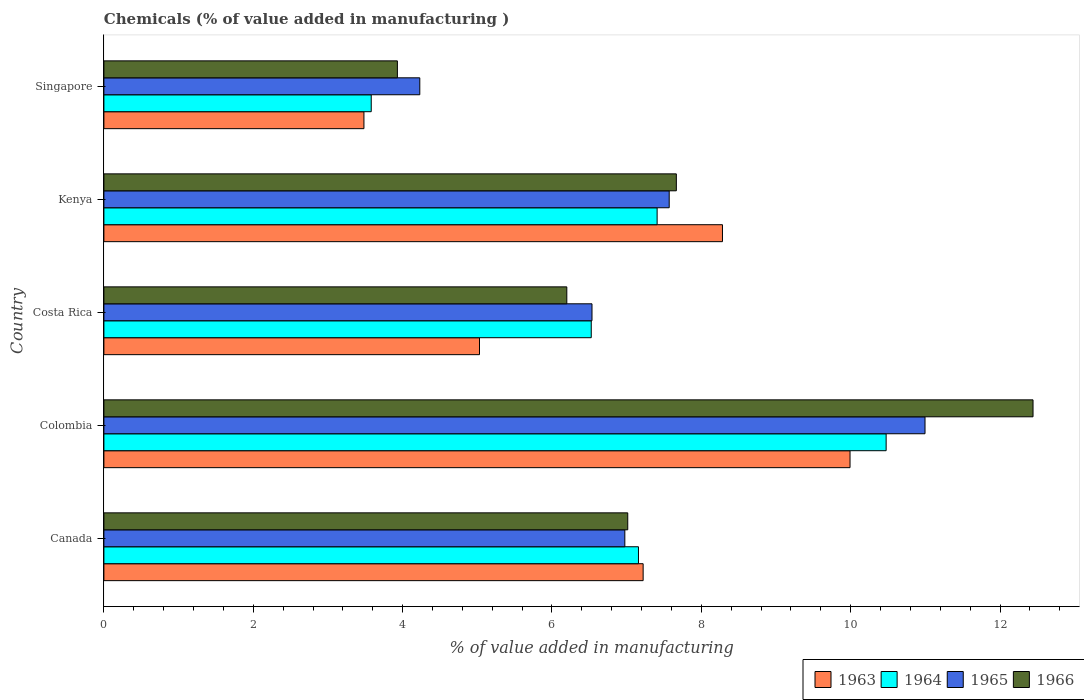How many groups of bars are there?
Give a very brief answer. 5. Are the number of bars per tick equal to the number of legend labels?
Make the answer very short. Yes. How many bars are there on the 4th tick from the bottom?
Offer a terse response. 4. What is the value added in manufacturing chemicals in 1964 in Kenya?
Make the answer very short. 7.41. Across all countries, what is the maximum value added in manufacturing chemicals in 1964?
Your answer should be compact. 10.47. Across all countries, what is the minimum value added in manufacturing chemicals in 1966?
Provide a succinct answer. 3.93. In which country was the value added in manufacturing chemicals in 1966 maximum?
Your answer should be compact. Colombia. In which country was the value added in manufacturing chemicals in 1965 minimum?
Your response must be concise. Singapore. What is the total value added in manufacturing chemicals in 1964 in the graph?
Make the answer very short. 35.15. What is the difference between the value added in manufacturing chemicals in 1965 in Canada and that in Singapore?
Your answer should be very brief. 2.75. What is the difference between the value added in manufacturing chemicals in 1965 in Colombia and the value added in manufacturing chemicals in 1963 in Kenya?
Your answer should be compact. 2.71. What is the average value added in manufacturing chemicals in 1966 per country?
Keep it short and to the point. 7.45. What is the difference between the value added in manufacturing chemicals in 1964 and value added in manufacturing chemicals in 1963 in Costa Rica?
Your answer should be very brief. 1.5. In how many countries, is the value added in manufacturing chemicals in 1964 greater than 6.4 %?
Your response must be concise. 4. What is the ratio of the value added in manufacturing chemicals in 1963 in Colombia to that in Singapore?
Offer a terse response. 2.87. Is the difference between the value added in manufacturing chemicals in 1964 in Kenya and Singapore greater than the difference between the value added in manufacturing chemicals in 1963 in Kenya and Singapore?
Give a very brief answer. No. What is the difference between the highest and the second highest value added in manufacturing chemicals in 1966?
Keep it short and to the point. 4.78. What is the difference between the highest and the lowest value added in manufacturing chemicals in 1966?
Ensure brevity in your answer.  8.51. In how many countries, is the value added in manufacturing chemicals in 1963 greater than the average value added in manufacturing chemicals in 1963 taken over all countries?
Make the answer very short. 3. Is the sum of the value added in manufacturing chemicals in 1966 in Canada and Costa Rica greater than the maximum value added in manufacturing chemicals in 1965 across all countries?
Your answer should be compact. Yes. What does the 2nd bar from the top in Singapore represents?
Your response must be concise. 1965. What does the 3rd bar from the bottom in Kenya represents?
Give a very brief answer. 1965. How many bars are there?
Your response must be concise. 20. How many countries are there in the graph?
Provide a succinct answer. 5. What is the difference between two consecutive major ticks on the X-axis?
Provide a succinct answer. 2. Are the values on the major ticks of X-axis written in scientific E-notation?
Your answer should be compact. No. Does the graph contain grids?
Your response must be concise. No. How many legend labels are there?
Your answer should be compact. 4. What is the title of the graph?
Provide a short and direct response. Chemicals (% of value added in manufacturing ). What is the label or title of the X-axis?
Offer a terse response. % of value added in manufacturing. What is the label or title of the Y-axis?
Offer a terse response. Country. What is the % of value added in manufacturing in 1963 in Canada?
Your answer should be compact. 7.22. What is the % of value added in manufacturing of 1964 in Canada?
Offer a terse response. 7.16. What is the % of value added in manufacturing in 1965 in Canada?
Provide a succinct answer. 6.98. What is the % of value added in manufacturing in 1966 in Canada?
Provide a succinct answer. 7.01. What is the % of value added in manufacturing in 1963 in Colombia?
Ensure brevity in your answer.  9.99. What is the % of value added in manufacturing in 1964 in Colombia?
Your response must be concise. 10.47. What is the % of value added in manufacturing of 1965 in Colombia?
Offer a terse response. 10.99. What is the % of value added in manufacturing in 1966 in Colombia?
Give a very brief answer. 12.44. What is the % of value added in manufacturing in 1963 in Costa Rica?
Your answer should be very brief. 5.03. What is the % of value added in manufacturing of 1964 in Costa Rica?
Offer a terse response. 6.53. What is the % of value added in manufacturing in 1965 in Costa Rica?
Offer a terse response. 6.54. What is the % of value added in manufacturing in 1966 in Costa Rica?
Give a very brief answer. 6.2. What is the % of value added in manufacturing of 1963 in Kenya?
Your answer should be compact. 8.28. What is the % of value added in manufacturing in 1964 in Kenya?
Give a very brief answer. 7.41. What is the % of value added in manufacturing of 1965 in Kenya?
Your answer should be very brief. 7.57. What is the % of value added in manufacturing in 1966 in Kenya?
Ensure brevity in your answer.  7.67. What is the % of value added in manufacturing in 1963 in Singapore?
Keep it short and to the point. 3.48. What is the % of value added in manufacturing of 1964 in Singapore?
Your answer should be very brief. 3.58. What is the % of value added in manufacturing of 1965 in Singapore?
Provide a short and direct response. 4.23. What is the % of value added in manufacturing of 1966 in Singapore?
Your answer should be compact. 3.93. Across all countries, what is the maximum % of value added in manufacturing in 1963?
Your answer should be compact. 9.99. Across all countries, what is the maximum % of value added in manufacturing of 1964?
Offer a terse response. 10.47. Across all countries, what is the maximum % of value added in manufacturing in 1965?
Your answer should be very brief. 10.99. Across all countries, what is the maximum % of value added in manufacturing in 1966?
Offer a very short reply. 12.44. Across all countries, what is the minimum % of value added in manufacturing of 1963?
Your answer should be compact. 3.48. Across all countries, what is the minimum % of value added in manufacturing of 1964?
Keep it short and to the point. 3.58. Across all countries, what is the minimum % of value added in manufacturing of 1965?
Ensure brevity in your answer.  4.23. Across all countries, what is the minimum % of value added in manufacturing in 1966?
Ensure brevity in your answer.  3.93. What is the total % of value added in manufacturing of 1963 in the graph?
Your answer should be compact. 34.01. What is the total % of value added in manufacturing in 1964 in the graph?
Keep it short and to the point. 35.15. What is the total % of value added in manufacturing of 1965 in the graph?
Ensure brevity in your answer.  36.31. What is the total % of value added in manufacturing in 1966 in the graph?
Keep it short and to the point. 37.25. What is the difference between the % of value added in manufacturing of 1963 in Canada and that in Colombia?
Your answer should be very brief. -2.77. What is the difference between the % of value added in manufacturing of 1964 in Canada and that in Colombia?
Offer a very short reply. -3.32. What is the difference between the % of value added in manufacturing of 1965 in Canada and that in Colombia?
Offer a very short reply. -4.02. What is the difference between the % of value added in manufacturing in 1966 in Canada and that in Colombia?
Ensure brevity in your answer.  -5.43. What is the difference between the % of value added in manufacturing of 1963 in Canada and that in Costa Rica?
Your answer should be very brief. 2.19. What is the difference between the % of value added in manufacturing of 1964 in Canada and that in Costa Rica?
Provide a short and direct response. 0.63. What is the difference between the % of value added in manufacturing in 1965 in Canada and that in Costa Rica?
Provide a succinct answer. 0.44. What is the difference between the % of value added in manufacturing of 1966 in Canada and that in Costa Rica?
Your response must be concise. 0.82. What is the difference between the % of value added in manufacturing of 1963 in Canada and that in Kenya?
Offer a terse response. -1.06. What is the difference between the % of value added in manufacturing in 1964 in Canada and that in Kenya?
Offer a very short reply. -0.25. What is the difference between the % of value added in manufacturing in 1965 in Canada and that in Kenya?
Your response must be concise. -0.59. What is the difference between the % of value added in manufacturing in 1966 in Canada and that in Kenya?
Your answer should be compact. -0.65. What is the difference between the % of value added in manufacturing of 1963 in Canada and that in Singapore?
Offer a very short reply. 3.74. What is the difference between the % of value added in manufacturing of 1964 in Canada and that in Singapore?
Keep it short and to the point. 3.58. What is the difference between the % of value added in manufacturing in 1965 in Canada and that in Singapore?
Provide a short and direct response. 2.75. What is the difference between the % of value added in manufacturing of 1966 in Canada and that in Singapore?
Ensure brevity in your answer.  3.08. What is the difference between the % of value added in manufacturing in 1963 in Colombia and that in Costa Rica?
Give a very brief answer. 4.96. What is the difference between the % of value added in manufacturing in 1964 in Colombia and that in Costa Rica?
Your answer should be compact. 3.95. What is the difference between the % of value added in manufacturing of 1965 in Colombia and that in Costa Rica?
Provide a short and direct response. 4.46. What is the difference between the % of value added in manufacturing in 1966 in Colombia and that in Costa Rica?
Offer a terse response. 6.24. What is the difference between the % of value added in manufacturing in 1963 in Colombia and that in Kenya?
Give a very brief answer. 1.71. What is the difference between the % of value added in manufacturing of 1964 in Colombia and that in Kenya?
Give a very brief answer. 3.07. What is the difference between the % of value added in manufacturing in 1965 in Colombia and that in Kenya?
Make the answer very short. 3.43. What is the difference between the % of value added in manufacturing in 1966 in Colombia and that in Kenya?
Your response must be concise. 4.78. What is the difference between the % of value added in manufacturing of 1963 in Colombia and that in Singapore?
Make the answer very short. 6.51. What is the difference between the % of value added in manufacturing in 1964 in Colombia and that in Singapore?
Keep it short and to the point. 6.89. What is the difference between the % of value added in manufacturing in 1965 in Colombia and that in Singapore?
Provide a short and direct response. 6.76. What is the difference between the % of value added in manufacturing in 1966 in Colombia and that in Singapore?
Provide a succinct answer. 8.51. What is the difference between the % of value added in manufacturing of 1963 in Costa Rica and that in Kenya?
Make the answer very short. -3.25. What is the difference between the % of value added in manufacturing in 1964 in Costa Rica and that in Kenya?
Provide a short and direct response. -0.88. What is the difference between the % of value added in manufacturing in 1965 in Costa Rica and that in Kenya?
Offer a terse response. -1.03. What is the difference between the % of value added in manufacturing of 1966 in Costa Rica and that in Kenya?
Ensure brevity in your answer.  -1.47. What is the difference between the % of value added in manufacturing of 1963 in Costa Rica and that in Singapore?
Offer a terse response. 1.55. What is the difference between the % of value added in manufacturing in 1964 in Costa Rica and that in Singapore?
Your answer should be very brief. 2.95. What is the difference between the % of value added in manufacturing of 1965 in Costa Rica and that in Singapore?
Offer a very short reply. 2.31. What is the difference between the % of value added in manufacturing in 1966 in Costa Rica and that in Singapore?
Offer a very short reply. 2.27. What is the difference between the % of value added in manufacturing in 1963 in Kenya and that in Singapore?
Keep it short and to the point. 4.8. What is the difference between the % of value added in manufacturing in 1964 in Kenya and that in Singapore?
Your response must be concise. 3.83. What is the difference between the % of value added in manufacturing in 1965 in Kenya and that in Singapore?
Provide a succinct answer. 3.34. What is the difference between the % of value added in manufacturing of 1966 in Kenya and that in Singapore?
Your answer should be compact. 3.74. What is the difference between the % of value added in manufacturing of 1963 in Canada and the % of value added in manufacturing of 1964 in Colombia?
Your response must be concise. -3.25. What is the difference between the % of value added in manufacturing in 1963 in Canada and the % of value added in manufacturing in 1965 in Colombia?
Offer a very short reply. -3.77. What is the difference between the % of value added in manufacturing in 1963 in Canada and the % of value added in manufacturing in 1966 in Colombia?
Keep it short and to the point. -5.22. What is the difference between the % of value added in manufacturing in 1964 in Canada and the % of value added in manufacturing in 1965 in Colombia?
Your response must be concise. -3.84. What is the difference between the % of value added in manufacturing in 1964 in Canada and the % of value added in manufacturing in 1966 in Colombia?
Offer a terse response. -5.28. What is the difference between the % of value added in manufacturing in 1965 in Canada and the % of value added in manufacturing in 1966 in Colombia?
Keep it short and to the point. -5.47. What is the difference between the % of value added in manufacturing of 1963 in Canada and the % of value added in manufacturing of 1964 in Costa Rica?
Offer a very short reply. 0.69. What is the difference between the % of value added in manufacturing in 1963 in Canada and the % of value added in manufacturing in 1965 in Costa Rica?
Your answer should be compact. 0.68. What is the difference between the % of value added in manufacturing in 1963 in Canada and the % of value added in manufacturing in 1966 in Costa Rica?
Provide a short and direct response. 1.02. What is the difference between the % of value added in manufacturing of 1964 in Canada and the % of value added in manufacturing of 1965 in Costa Rica?
Provide a short and direct response. 0.62. What is the difference between the % of value added in manufacturing of 1964 in Canada and the % of value added in manufacturing of 1966 in Costa Rica?
Provide a short and direct response. 0.96. What is the difference between the % of value added in manufacturing of 1965 in Canada and the % of value added in manufacturing of 1966 in Costa Rica?
Keep it short and to the point. 0.78. What is the difference between the % of value added in manufacturing in 1963 in Canada and the % of value added in manufacturing in 1964 in Kenya?
Ensure brevity in your answer.  -0.19. What is the difference between the % of value added in manufacturing of 1963 in Canada and the % of value added in manufacturing of 1965 in Kenya?
Keep it short and to the point. -0.35. What is the difference between the % of value added in manufacturing of 1963 in Canada and the % of value added in manufacturing of 1966 in Kenya?
Give a very brief answer. -0.44. What is the difference between the % of value added in manufacturing of 1964 in Canada and the % of value added in manufacturing of 1965 in Kenya?
Provide a succinct answer. -0.41. What is the difference between the % of value added in manufacturing of 1964 in Canada and the % of value added in manufacturing of 1966 in Kenya?
Give a very brief answer. -0.51. What is the difference between the % of value added in manufacturing in 1965 in Canada and the % of value added in manufacturing in 1966 in Kenya?
Offer a very short reply. -0.69. What is the difference between the % of value added in manufacturing of 1963 in Canada and the % of value added in manufacturing of 1964 in Singapore?
Give a very brief answer. 3.64. What is the difference between the % of value added in manufacturing in 1963 in Canada and the % of value added in manufacturing in 1965 in Singapore?
Provide a succinct answer. 2.99. What is the difference between the % of value added in manufacturing in 1963 in Canada and the % of value added in manufacturing in 1966 in Singapore?
Offer a terse response. 3.29. What is the difference between the % of value added in manufacturing in 1964 in Canada and the % of value added in manufacturing in 1965 in Singapore?
Keep it short and to the point. 2.93. What is the difference between the % of value added in manufacturing of 1964 in Canada and the % of value added in manufacturing of 1966 in Singapore?
Your answer should be very brief. 3.23. What is the difference between the % of value added in manufacturing in 1965 in Canada and the % of value added in manufacturing in 1966 in Singapore?
Make the answer very short. 3.05. What is the difference between the % of value added in manufacturing of 1963 in Colombia and the % of value added in manufacturing of 1964 in Costa Rica?
Offer a very short reply. 3.47. What is the difference between the % of value added in manufacturing in 1963 in Colombia and the % of value added in manufacturing in 1965 in Costa Rica?
Provide a short and direct response. 3.46. What is the difference between the % of value added in manufacturing in 1963 in Colombia and the % of value added in manufacturing in 1966 in Costa Rica?
Offer a terse response. 3.79. What is the difference between the % of value added in manufacturing of 1964 in Colombia and the % of value added in manufacturing of 1965 in Costa Rica?
Ensure brevity in your answer.  3.94. What is the difference between the % of value added in manufacturing of 1964 in Colombia and the % of value added in manufacturing of 1966 in Costa Rica?
Offer a terse response. 4.28. What is the difference between the % of value added in manufacturing of 1965 in Colombia and the % of value added in manufacturing of 1966 in Costa Rica?
Offer a terse response. 4.8. What is the difference between the % of value added in manufacturing of 1963 in Colombia and the % of value added in manufacturing of 1964 in Kenya?
Make the answer very short. 2.58. What is the difference between the % of value added in manufacturing in 1963 in Colombia and the % of value added in manufacturing in 1965 in Kenya?
Your response must be concise. 2.42. What is the difference between the % of value added in manufacturing in 1963 in Colombia and the % of value added in manufacturing in 1966 in Kenya?
Provide a succinct answer. 2.33. What is the difference between the % of value added in manufacturing of 1964 in Colombia and the % of value added in manufacturing of 1965 in Kenya?
Offer a very short reply. 2.9. What is the difference between the % of value added in manufacturing in 1964 in Colombia and the % of value added in manufacturing in 1966 in Kenya?
Give a very brief answer. 2.81. What is the difference between the % of value added in manufacturing of 1965 in Colombia and the % of value added in manufacturing of 1966 in Kenya?
Give a very brief answer. 3.33. What is the difference between the % of value added in manufacturing in 1963 in Colombia and the % of value added in manufacturing in 1964 in Singapore?
Keep it short and to the point. 6.41. What is the difference between the % of value added in manufacturing of 1963 in Colombia and the % of value added in manufacturing of 1965 in Singapore?
Your answer should be very brief. 5.76. What is the difference between the % of value added in manufacturing in 1963 in Colombia and the % of value added in manufacturing in 1966 in Singapore?
Make the answer very short. 6.06. What is the difference between the % of value added in manufacturing in 1964 in Colombia and the % of value added in manufacturing in 1965 in Singapore?
Make the answer very short. 6.24. What is the difference between the % of value added in manufacturing in 1964 in Colombia and the % of value added in manufacturing in 1966 in Singapore?
Your response must be concise. 6.54. What is the difference between the % of value added in manufacturing of 1965 in Colombia and the % of value added in manufacturing of 1966 in Singapore?
Keep it short and to the point. 7.07. What is the difference between the % of value added in manufacturing in 1963 in Costa Rica and the % of value added in manufacturing in 1964 in Kenya?
Provide a succinct answer. -2.38. What is the difference between the % of value added in manufacturing of 1963 in Costa Rica and the % of value added in manufacturing of 1965 in Kenya?
Ensure brevity in your answer.  -2.54. What is the difference between the % of value added in manufacturing in 1963 in Costa Rica and the % of value added in manufacturing in 1966 in Kenya?
Offer a very short reply. -2.64. What is the difference between the % of value added in manufacturing of 1964 in Costa Rica and the % of value added in manufacturing of 1965 in Kenya?
Make the answer very short. -1.04. What is the difference between the % of value added in manufacturing of 1964 in Costa Rica and the % of value added in manufacturing of 1966 in Kenya?
Your answer should be very brief. -1.14. What is the difference between the % of value added in manufacturing of 1965 in Costa Rica and the % of value added in manufacturing of 1966 in Kenya?
Provide a succinct answer. -1.13. What is the difference between the % of value added in manufacturing in 1963 in Costa Rica and the % of value added in manufacturing in 1964 in Singapore?
Ensure brevity in your answer.  1.45. What is the difference between the % of value added in manufacturing in 1963 in Costa Rica and the % of value added in manufacturing in 1965 in Singapore?
Your answer should be compact. 0.8. What is the difference between the % of value added in manufacturing in 1963 in Costa Rica and the % of value added in manufacturing in 1966 in Singapore?
Your response must be concise. 1.1. What is the difference between the % of value added in manufacturing in 1964 in Costa Rica and the % of value added in manufacturing in 1965 in Singapore?
Make the answer very short. 2.3. What is the difference between the % of value added in manufacturing of 1964 in Costa Rica and the % of value added in manufacturing of 1966 in Singapore?
Your answer should be compact. 2.6. What is the difference between the % of value added in manufacturing in 1965 in Costa Rica and the % of value added in manufacturing in 1966 in Singapore?
Give a very brief answer. 2.61. What is the difference between the % of value added in manufacturing in 1963 in Kenya and the % of value added in manufacturing in 1964 in Singapore?
Provide a succinct answer. 4.7. What is the difference between the % of value added in manufacturing of 1963 in Kenya and the % of value added in manufacturing of 1965 in Singapore?
Your response must be concise. 4.05. What is the difference between the % of value added in manufacturing of 1963 in Kenya and the % of value added in manufacturing of 1966 in Singapore?
Make the answer very short. 4.35. What is the difference between the % of value added in manufacturing in 1964 in Kenya and the % of value added in manufacturing in 1965 in Singapore?
Your answer should be very brief. 3.18. What is the difference between the % of value added in manufacturing of 1964 in Kenya and the % of value added in manufacturing of 1966 in Singapore?
Provide a short and direct response. 3.48. What is the difference between the % of value added in manufacturing in 1965 in Kenya and the % of value added in manufacturing in 1966 in Singapore?
Provide a succinct answer. 3.64. What is the average % of value added in manufacturing in 1963 per country?
Offer a terse response. 6.8. What is the average % of value added in manufacturing in 1964 per country?
Ensure brevity in your answer.  7.03. What is the average % of value added in manufacturing of 1965 per country?
Your response must be concise. 7.26. What is the average % of value added in manufacturing in 1966 per country?
Offer a terse response. 7.45. What is the difference between the % of value added in manufacturing in 1963 and % of value added in manufacturing in 1964 in Canada?
Provide a short and direct response. 0.06. What is the difference between the % of value added in manufacturing in 1963 and % of value added in manufacturing in 1965 in Canada?
Your response must be concise. 0.25. What is the difference between the % of value added in manufacturing of 1963 and % of value added in manufacturing of 1966 in Canada?
Give a very brief answer. 0.21. What is the difference between the % of value added in manufacturing of 1964 and % of value added in manufacturing of 1965 in Canada?
Keep it short and to the point. 0.18. What is the difference between the % of value added in manufacturing of 1964 and % of value added in manufacturing of 1966 in Canada?
Your answer should be very brief. 0.14. What is the difference between the % of value added in manufacturing of 1965 and % of value added in manufacturing of 1966 in Canada?
Give a very brief answer. -0.04. What is the difference between the % of value added in manufacturing in 1963 and % of value added in manufacturing in 1964 in Colombia?
Provide a succinct answer. -0.48. What is the difference between the % of value added in manufacturing of 1963 and % of value added in manufacturing of 1965 in Colombia?
Your answer should be compact. -1. What is the difference between the % of value added in manufacturing in 1963 and % of value added in manufacturing in 1966 in Colombia?
Give a very brief answer. -2.45. What is the difference between the % of value added in manufacturing in 1964 and % of value added in manufacturing in 1965 in Colombia?
Keep it short and to the point. -0.52. What is the difference between the % of value added in manufacturing in 1964 and % of value added in manufacturing in 1966 in Colombia?
Offer a terse response. -1.97. What is the difference between the % of value added in manufacturing of 1965 and % of value added in manufacturing of 1966 in Colombia?
Provide a short and direct response. -1.45. What is the difference between the % of value added in manufacturing of 1963 and % of value added in manufacturing of 1964 in Costa Rica?
Offer a very short reply. -1.5. What is the difference between the % of value added in manufacturing of 1963 and % of value added in manufacturing of 1965 in Costa Rica?
Give a very brief answer. -1.51. What is the difference between the % of value added in manufacturing of 1963 and % of value added in manufacturing of 1966 in Costa Rica?
Make the answer very short. -1.17. What is the difference between the % of value added in manufacturing in 1964 and % of value added in manufacturing in 1965 in Costa Rica?
Your answer should be compact. -0.01. What is the difference between the % of value added in manufacturing of 1964 and % of value added in manufacturing of 1966 in Costa Rica?
Provide a succinct answer. 0.33. What is the difference between the % of value added in manufacturing in 1965 and % of value added in manufacturing in 1966 in Costa Rica?
Your answer should be very brief. 0.34. What is the difference between the % of value added in manufacturing in 1963 and % of value added in manufacturing in 1964 in Kenya?
Provide a short and direct response. 0.87. What is the difference between the % of value added in manufacturing in 1963 and % of value added in manufacturing in 1965 in Kenya?
Provide a short and direct response. 0.71. What is the difference between the % of value added in manufacturing of 1963 and % of value added in manufacturing of 1966 in Kenya?
Your response must be concise. 0.62. What is the difference between the % of value added in manufacturing of 1964 and % of value added in manufacturing of 1965 in Kenya?
Provide a succinct answer. -0.16. What is the difference between the % of value added in manufacturing in 1964 and % of value added in manufacturing in 1966 in Kenya?
Provide a short and direct response. -0.26. What is the difference between the % of value added in manufacturing of 1965 and % of value added in manufacturing of 1966 in Kenya?
Ensure brevity in your answer.  -0.1. What is the difference between the % of value added in manufacturing of 1963 and % of value added in manufacturing of 1964 in Singapore?
Your response must be concise. -0.1. What is the difference between the % of value added in manufacturing of 1963 and % of value added in manufacturing of 1965 in Singapore?
Ensure brevity in your answer.  -0.75. What is the difference between the % of value added in manufacturing of 1963 and % of value added in manufacturing of 1966 in Singapore?
Make the answer very short. -0.45. What is the difference between the % of value added in manufacturing of 1964 and % of value added in manufacturing of 1965 in Singapore?
Ensure brevity in your answer.  -0.65. What is the difference between the % of value added in manufacturing of 1964 and % of value added in manufacturing of 1966 in Singapore?
Keep it short and to the point. -0.35. What is the difference between the % of value added in manufacturing in 1965 and % of value added in manufacturing in 1966 in Singapore?
Provide a short and direct response. 0.3. What is the ratio of the % of value added in manufacturing of 1963 in Canada to that in Colombia?
Give a very brief answer. 0.72. What is the ratio of the % of value added in manufacturing of 1964 in Canada to that in Colombia?
Ensure brevity in your answer.  0.68. What is the ratio of the % of value added in manufacturing of 1965 in Canada to that in Colombia?
Offer a terse response. 0.63. What is the ratio of the % of value added in manufacturing of 1966 in Canada to that in Colombia?
Your response must be concise. 0.56. What is the ratio of the % of value added in manufacturing of 1963 in Canada to that in Costa Rica?
Provide a succinct answer. 1.44. What is the ratio of the % of value added in manufacturing in 1964 in Canada to that in Costa Rica?
Ensure brevity in your answer.  1.1. What is the ratio of the % of value added in manufacturing in 1965 in Canada to that in Costa Rica?
Your answer should be very brief. 1.07. What is the ratio of the % of value added in manufacturing in 1966 in Canada to that in Costa Rica?
Your answer should be very brief. 1.13. What is the ratio of the % of value added in manufacturing of 1963 in Canada to that in Kenya?
Provide a short and direct response. 0.87. What is the ratio of the % of value added in manufacturing in 1964 in Canada to that in Kenya?
Offer a terse response. 0.97. What is the ratio of the % of value added in manufacturing of 1965 in Canada to that in Kenya?
Provide a short and direct response. 0.92. What is the ratio of the % of value added in manufacturing of 1966 in Canada to that in Kenya?
Make the answer very short. 0.92. What is the ratio of the % of value added in manufacturing in 1963 in Canada to that in Singapore?
Provide a short and direct response. 2.07. What is the ratio of the % of value added in manufacturing in 1964 in Canada to that in Singapore?
Your response must be concise. 2. What is the ratio of the % of value added in manufacturing in 1965 in Canada to that in Singapore?
Provide a succinct answer. 1.65. What is the ratio of the % of value added in manufacturing in 1966 in Canada to that in Singapore?
Provide a short and direct response. 1.78. What is the ratio of the % of value added in manufacturing in 1963 in Colombia to that in Costa Rica?
Provide a succinct answer. 1.99. What is the ratio of the % of value added in manufacturing of 1964 in Colombia to that in Costa Rica?
Provide a short and direct response. 1.61. What is the ratio of the % of value added in manufacturing of 1965 in Colombia to that in Costa Rica?
Ensure brevity in your answer.  1.68. What is the ratio of the % of value added in manufacturing in 1966 in Colombia to that in Costa Rica?
Provide a short and direct response. 2.01. What is the ratio of the % of value added in manufacturing of 1963 in Colombia to that in Kenya?
Make the answer very short. 1.21. What is the ratio of the % of value added in manufacturing of 1964 in Colombia to that in Kenya?
Keep it short and to the point. 1.41. What is the ratio of the % of value added in manufacturing in 1965 in Colombia to that in Kenya?
Offer a terse response. 1.45. What is the ratio of the % of value added in manufacturing of 1966 in Colombia to that in Kenya?
Ensure brevity in your answer.  1.62. What is the ratio of the % of value added in manufacturing of 1963 in Colombia to that in Singapore?
Your answer should be compact. 2.87. What is the ratio of the % of value added in manufacturing in 1964 in Colombia to that in Singapore?
Provide a short and direct response. 2.93. What is the ratio of the % of value added in manufacturing in 1965 in Colombia to that in Singapore?
Offer a terse response. 2.6. What is the ratio of the % of value added in manufacturing in 1966 in Colombia to that in Singapore?
Your answer should be very brief. 3.17. What is the ratio of the % of value added in manufacturing in 1963 in Costa Rica to that in Kenya?
Provide a succinct answer. 0.61. What is the ratio of the % of value added in manufacturing in 1964 in Costa Rica to that in Kenya?
Provide a short and direct response. 0.88. What is the ratio of the % of value added in manufacturing in 1965 in Costa Rica to that in Kenya?
Make the answer very short. 0.86. What is the ratio of the % of value added in manufacturing in 1966 in Costa Rica to that in Kenya?
Your response must be concise. 0.81. What is the ratio of the % of value added in manufacturing in 1963 in Costa Rica to that in Singapore?
Offer a terse response. 1.44. What is the ratio of the % of value added in manufacturing of 1964 in Costa Rica to that in Singapore?
Provide a short and direct response. 1.82. What is the ratio of the % of value added in manufacturing of 1965 in Costa Rica to that in Singapore?
Your answer should be compact. 1.55. What is the ratio of the % of value added in manufacturing in 1966 in Costa Rica to that in Singapore?
Provide a short and direct response. 1.58. What is the ratio of the % of value added in manufacturing in 1963 in Kenya to that in Singapore?
Your answer should be compact. 2.38. What is the ratio of the % of value added in manufacturing in 1964 in Kenya to that in Singapore?
Ensure brevity in your answer.  2.07. What is the ratio of the % of value added in manufacturing in 1965 in Kenya to that in Singapore?
Provide a short and direct response. 1.79. What is the ratio of the % of value added in manufacturing of 1966 in Kenya to that in Singapore?
Ensure brevity in your answer.  1.95. What is the difference between the highest and the second highest % of value added in manufacturing in 1963?
Provide a short and direct response. 1.71. What is the difference between the highest and the second highest % of value added in manufacturing in 1964?
Make the answer very short. 3.07. What is the difference between the highest and the second highest % of value added in manufacturing in 1965?
Your answer should be very brief. 3.43. What is the difference between the highest and the second highest % of value added in manufacturing in 1966?
Ensure brevity in your answer.  4.78. What is the difference between the highest and the lowest % of value added in manufacturing in 1963?
Ensure brevity in your answer.  6.51. What is the difference between the highest and the lowest % of value added in manufacturing in 1964?
Keep it short and to the point. 6.89. What is the difference between the highest and the lowest % of value added in manufacturing of 1965?
Your answer should be very brief. 6.76. What is the difference between the highest and the lowest % of value added in manufacturing of 1966?
Your answer should be compact. 8.51. 